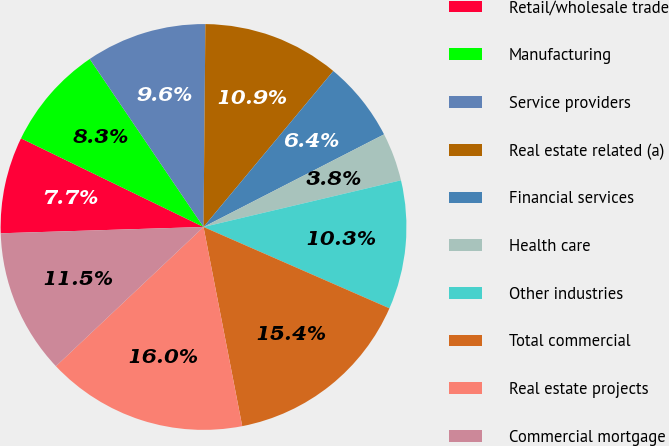Convert chart to OTSL. <chart><loc_0><loc_0><loc_500><loc_500><pie_chart><fcel>Retail/wholesale trade<fcel>Manufacturing<fcel>Service providers<fcel>Real estate related (a)<fcel>Financial services<fcel>Health care<fcel>Other industries<fcel>Total commercial<fcel>Real estate projects<fcel>Commercial mortgage<nl><fcel>7.69%<fcel>8.33%<fcel>9.62%<fcel>10.9%<fcel>6.41%<fcel>3.85%<fcel>10.26%<fcel>15.38%<fcel>16.02%<fcel>11.54%<nl></chart> 